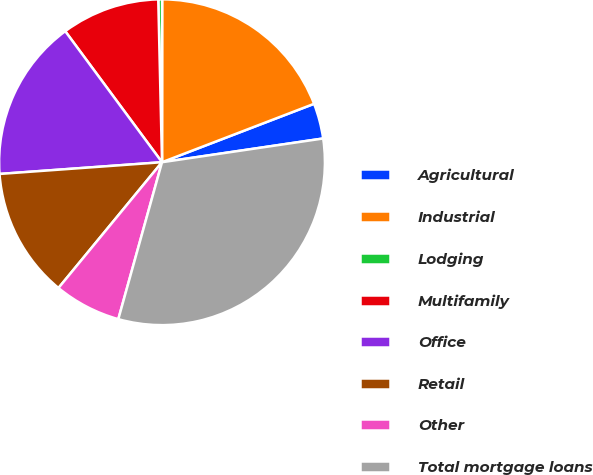Convert chart to OTSL. <chart><loc_0><loc_0><loc_500><loc_500><pie_chart><fcel>Agricultural<fcel>Industrial<fcel>Lodging<fcel>Multifamily<fcel>Office<fcel>Retail<fcel>Other<fcel>Total mortgage loans<nl><fcel>3.51%<fcel>19.15%<fcel>0.38%<fcel>9.76%<fcel>16.02%<fcel>12.89%<fcel>6.64%<fcel>31.65%<nl></chart> 